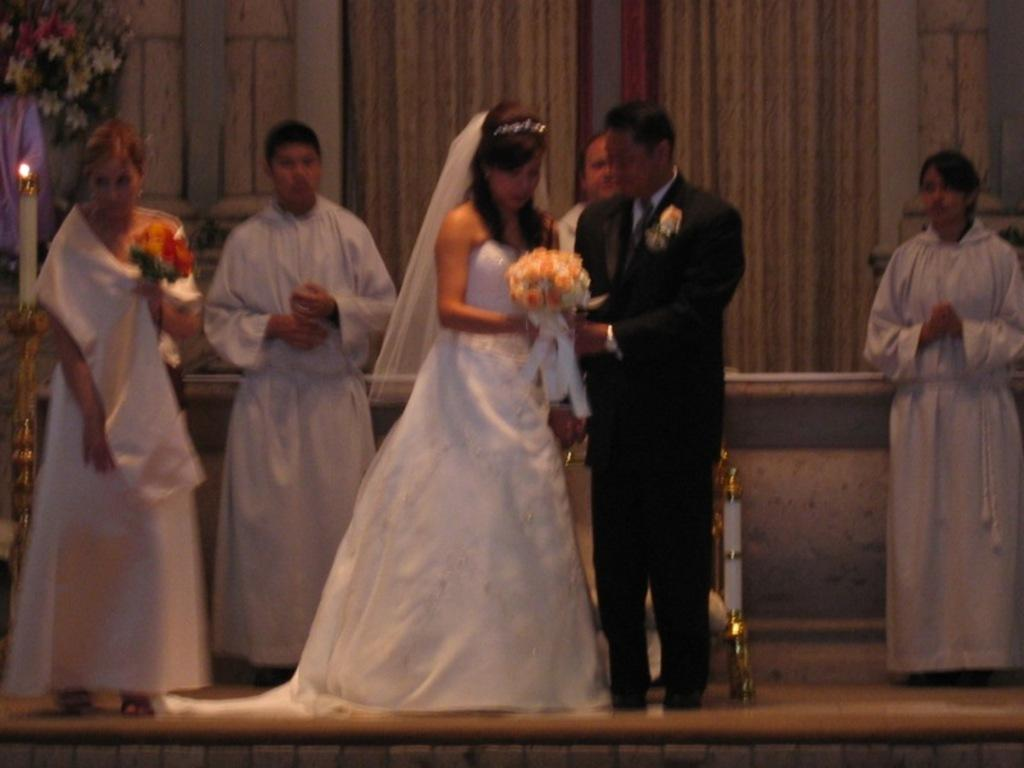Who are the two people in the image? There is a couple in the image. What are the couple doing in the image? The couple is standing and holding a boutique. Can you describe the background of the image? There are people, curtains, and pillars in the background of the image. What type of hearing aid is the man wearing in the image? There is no mention of a hearing aid or any indication that the man is wearing one in the image. 